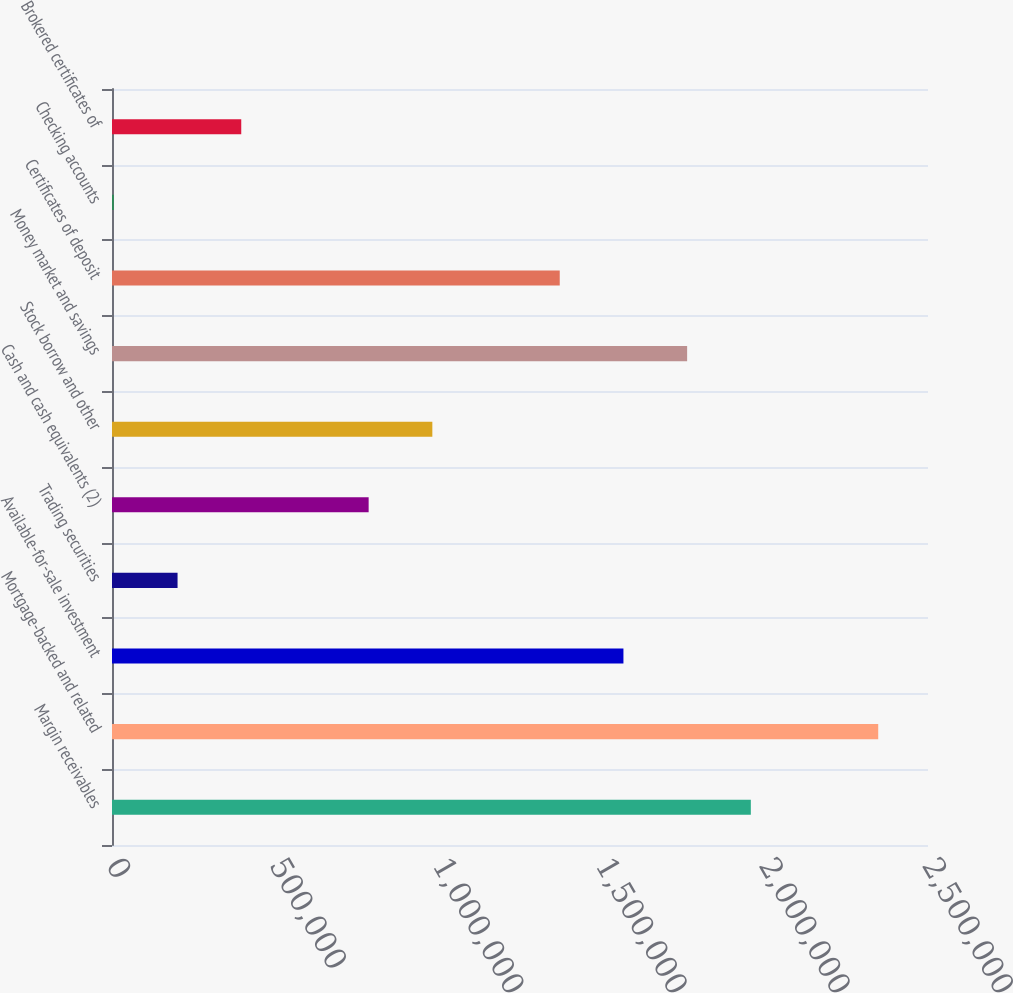<chart> <loc_0><loc_0><loc_500><loc_500><bar_chart><fcel>Margin receivables<fcel>Mortgage-backed and related<fcel>Available-for-sale investment<fcel>Trading securities<fcel>Cash and cash equivalents (2)<fcel>Stock borrow and other<fcel>Money market and savings<fcel>Certificates of deposit<fcel>Checking accounts<fcel>Brokered certificates of<nl><fcel>1.9572e+06<fcel>2.3475e+06<fcel>1.5669e+06<fcel>200840<fcel>786294<fcel>981446<fcel>1.76205e+06<fcel>1.37175e+06<fcel>5689<fcel>395992<nl></chart> 